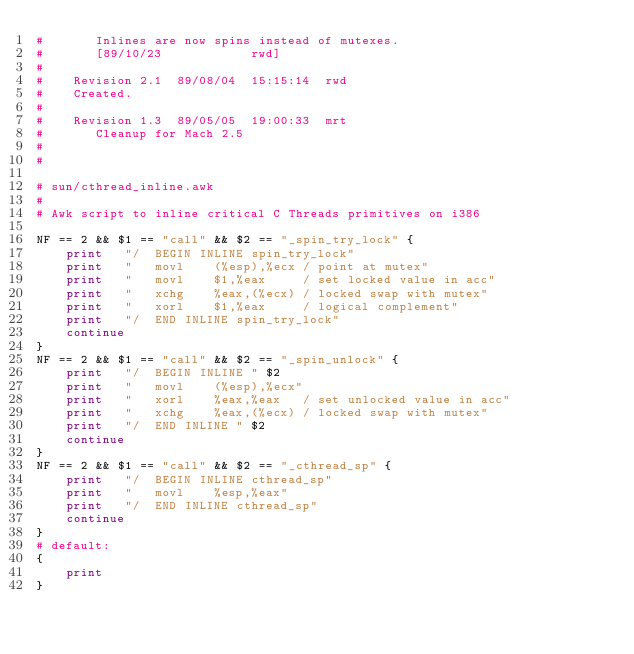Convert code to text. <code><loc_0><loc_0><loc_500><loc_500><_Awk_>#	 	Inlines are now spins instead of mutexes.
#	 	[89/10/23            rwd]
#	 
#	 Revision 2.1  89/08/04  15:15:14  rwd
#	 Created.
#	 
#	 Revision 1.3  89/05/05  19:00:33  mrt
#	 	Cleanup for Mach 2.5
#	 
#

# sun/cthread_inline.awk
#
# Awk script to inline critical C Threads primitives on i386

NF == 2 && $1 == "call" && $2 == "_spin_try_lock" {
	print	"/	BEGIN INLINE spin_try_lock"
	print	"	movl	(%esp),%ecx	/ point at mutex"
	print	"	movl	$1,%eax		/ set locked value in acc"
	print	"	xchg	%eax,(%ecx)	/ locked swap with mutex"
	print	"	xorl	$1,%eax		/ logical complement"
	print	"/	END INLINE spin_try_lock"
	continue
}
NF == 2 && $1 == "call" && $2 == "_spin_unlock" {
	print	"/	BEGIN INLINE " $2
	print	"	movl	(%esp),%ecx"
	print	"	xorl	%eax,%eax	/ set unlocked value in acc"
	print	"	xchg	%eax,(%ecx)	/ locked swap with mutex"
	print	"/	END INLINE " $2
	continue
}
NF == 2 && $1 == "call" && $2 == "_cthread_sp" {
	print	"/	BEGIN INLINE cthread_sp"
	print	"	movl	%esp,%eax"
	print	"/	END INLINE cthread_sp"
	continue
}
# default:
{
	print
}
</code> 